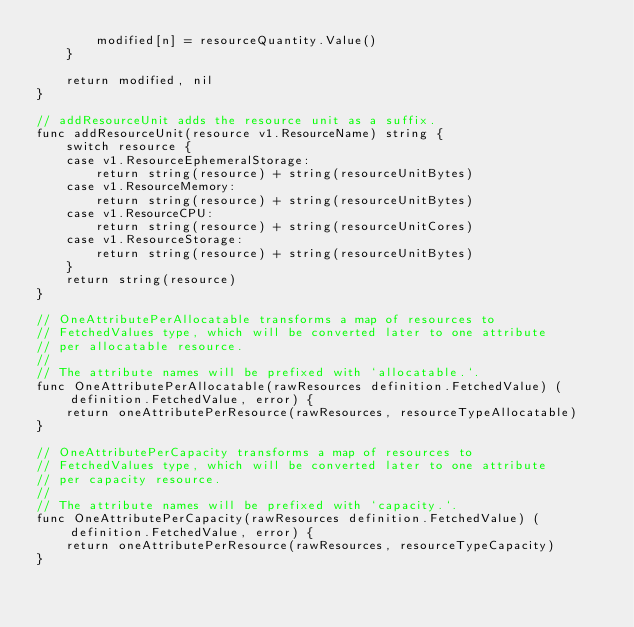Convert code to text. <code><loc_0><loc_0><loc_500><loc_500><_Go_>		modified[n] = resourceQuantity.Value()
	}

	return modified, nil
}

// addResourceUnit adds the resource unit as a suffix.
func addResourceUnit(resource v1.ResourceName) string {
	switch resource {
	case v1.ResourceEphemeralStorage:
		return string(resource) + string(resourceUnitBytes)
	case v1.ResourceMemory:
		return string(resource) + string(resourceUnitBytes)
	case v1.ResourceCPU:
		return string(resource) + string(resourceUnitCores)
	case v1.ResourceStorage:
		return string(resource) + string(resourceUnitBytes)
	}
	return string(resource)
}

// OneAttributePerAllocatable transforms a map of resources to
// FetchedValues type, which will be converted later to one attribute
// per allocatable resource.
//
// The attribute names will be prefixed with `allocatable.`.
func OneAttributePerAllocatable(rawResources definition.FetchedValue) (definition.FetchedValue, error) {
	return oneAttributePerResource(rawResources, resourceTypeAllocatable)
}

// OneAttributePerCapacity transforms a map of resources to
// FetchedValues type, which will be converted later to one attribute
// per capacity resource.
//
// The attribute names will be prefixed with `capacity.`.
func OneAttributePerCapacity(rawResources definition.FetchedValue) (definition.FetchedValue, error) {
	return oneAttributePerResource(rawResources, resourceTypeCapacity)
}
</code> 